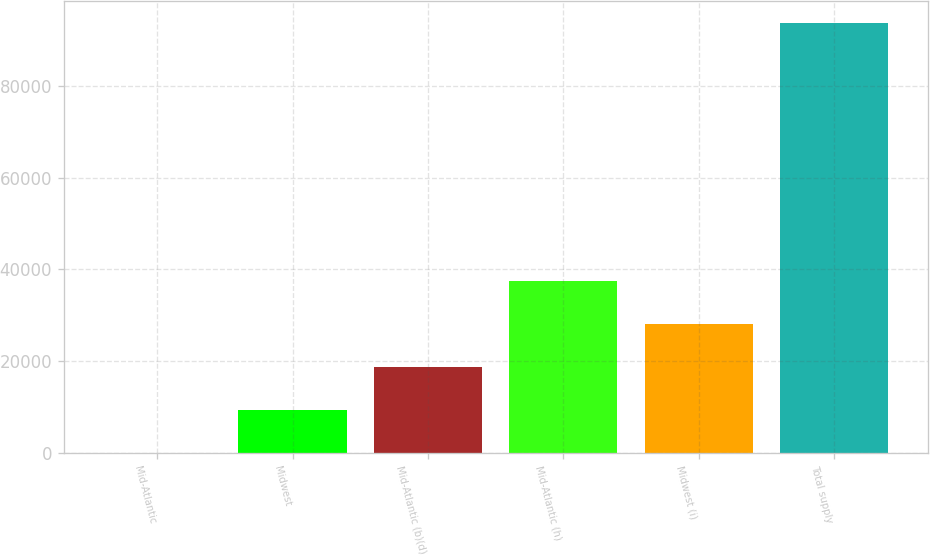<chart> <loc_0><loc_0><loc_500><loc_500><bar_chart><fcel>Mid-Atlantic<fcel>Midwest<fcel>Mid-Atlantic (b)(d)<fcel>Mid-Atlantic (h)<fcel>Midwest (i)<fcel>Total supply<nl><fcel>50<fcel>9430.2<fcel>18810.4<fcel>37570.8<fcel>28190.6<fcel>93852<nl></chart> 